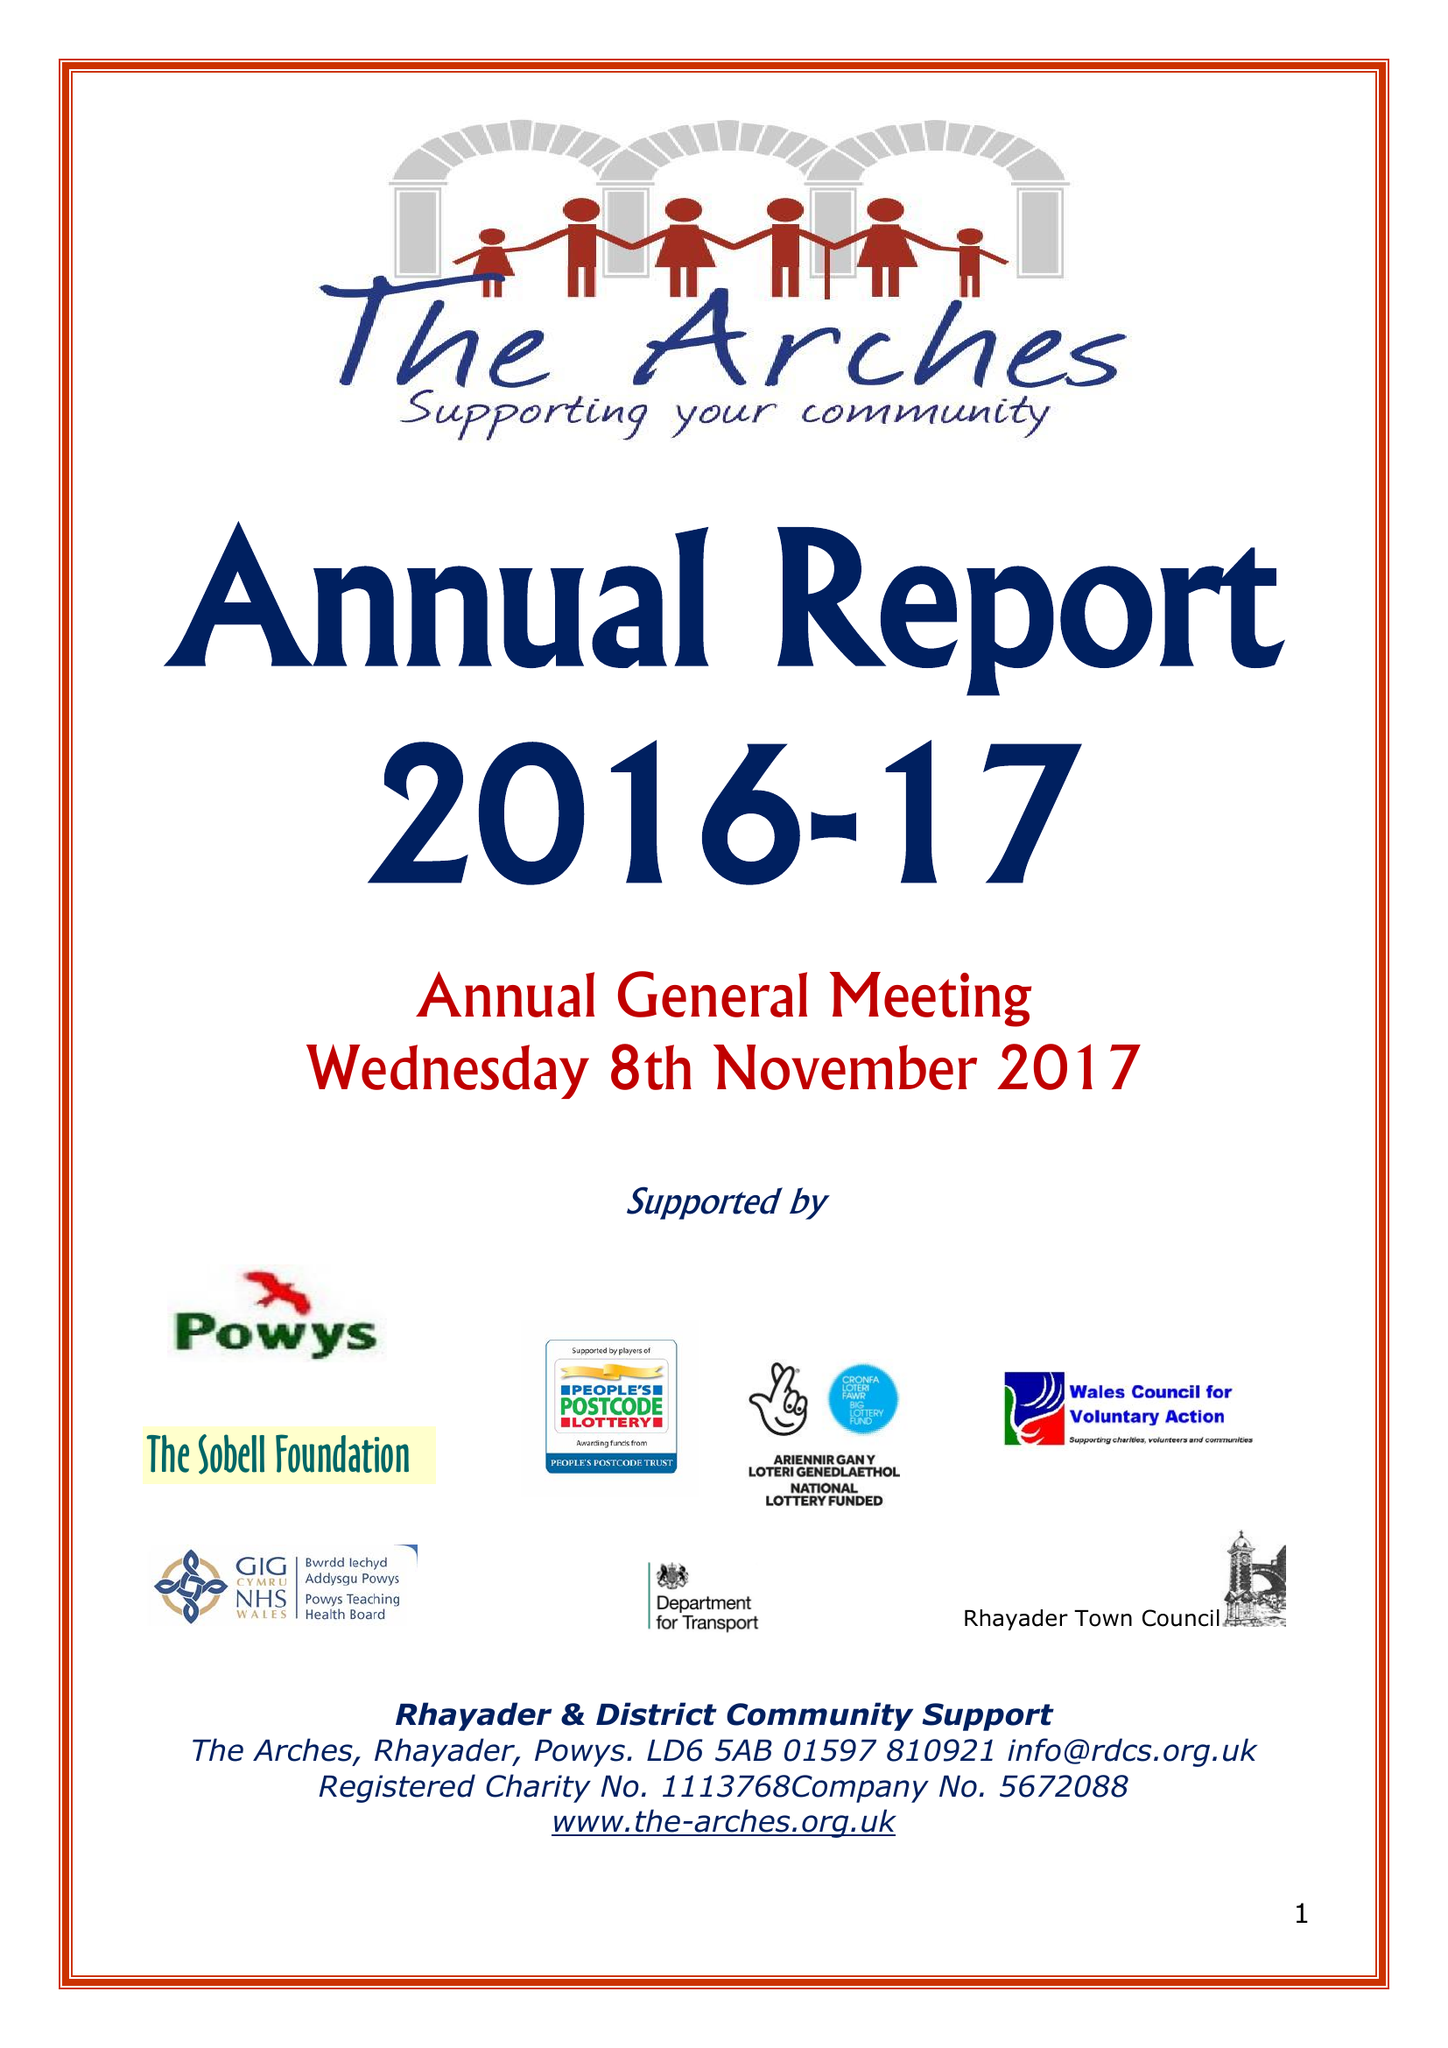What is the value for the address__post_town?
Answer the question using a single word or phrase. RHAYADER 